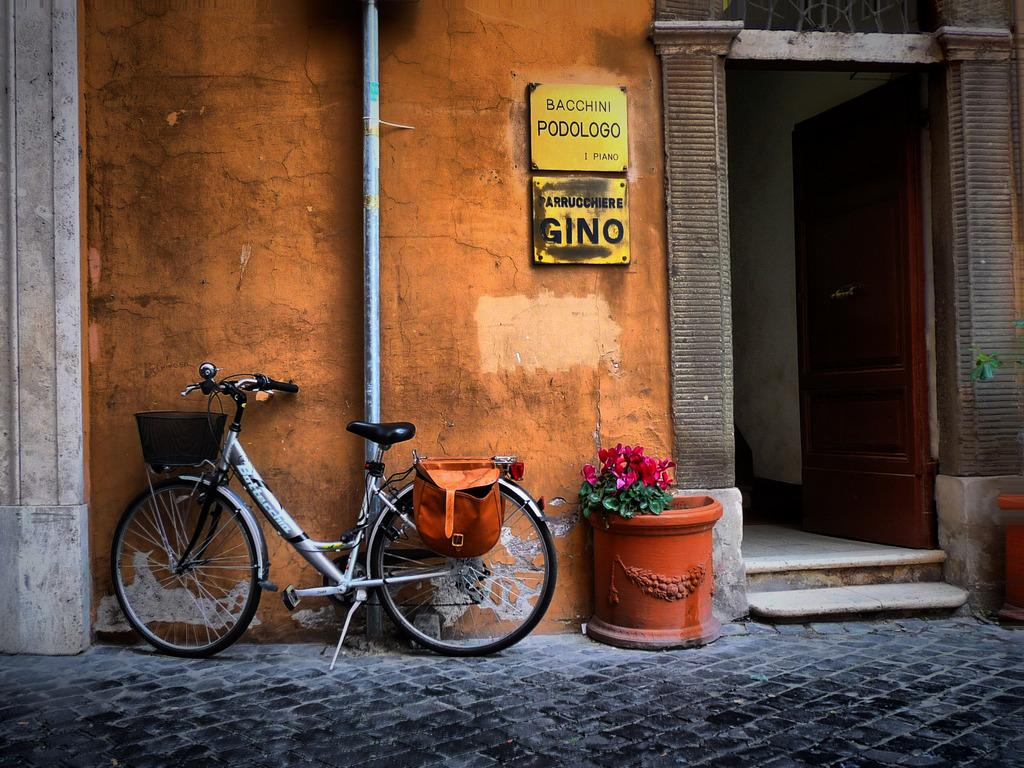What is parked on the path of the road in the image? There is a cycle parked on the path of the road in the image. What is located beside the cycle? The cycle is beside a flower pot. What can be seen in the background of the image? There is a building in the background of the image. How many friends are sitting on the cycle in the image? There are no friends sitting on the cycle in the image; it is parked and unoccupied. 